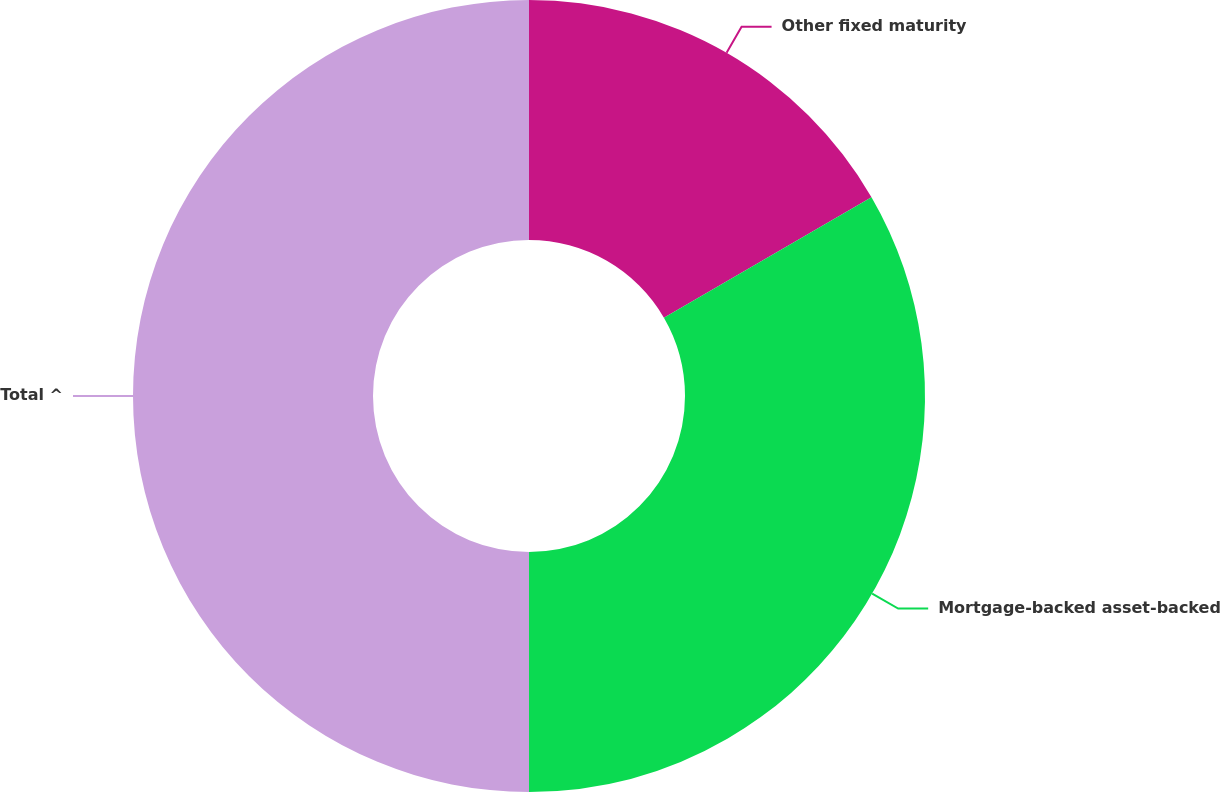Convert chart to OTSL. <chart><loc_0><loc_0><loc_500><loc_500><pie_chart><fcel>Other fixed maturity<fcel>Mortgage-backed asset-backed<fcel>Total ^<nl><fcel>16.63%<fcel>33.37%<fcel>50.0%<nl></chart> 